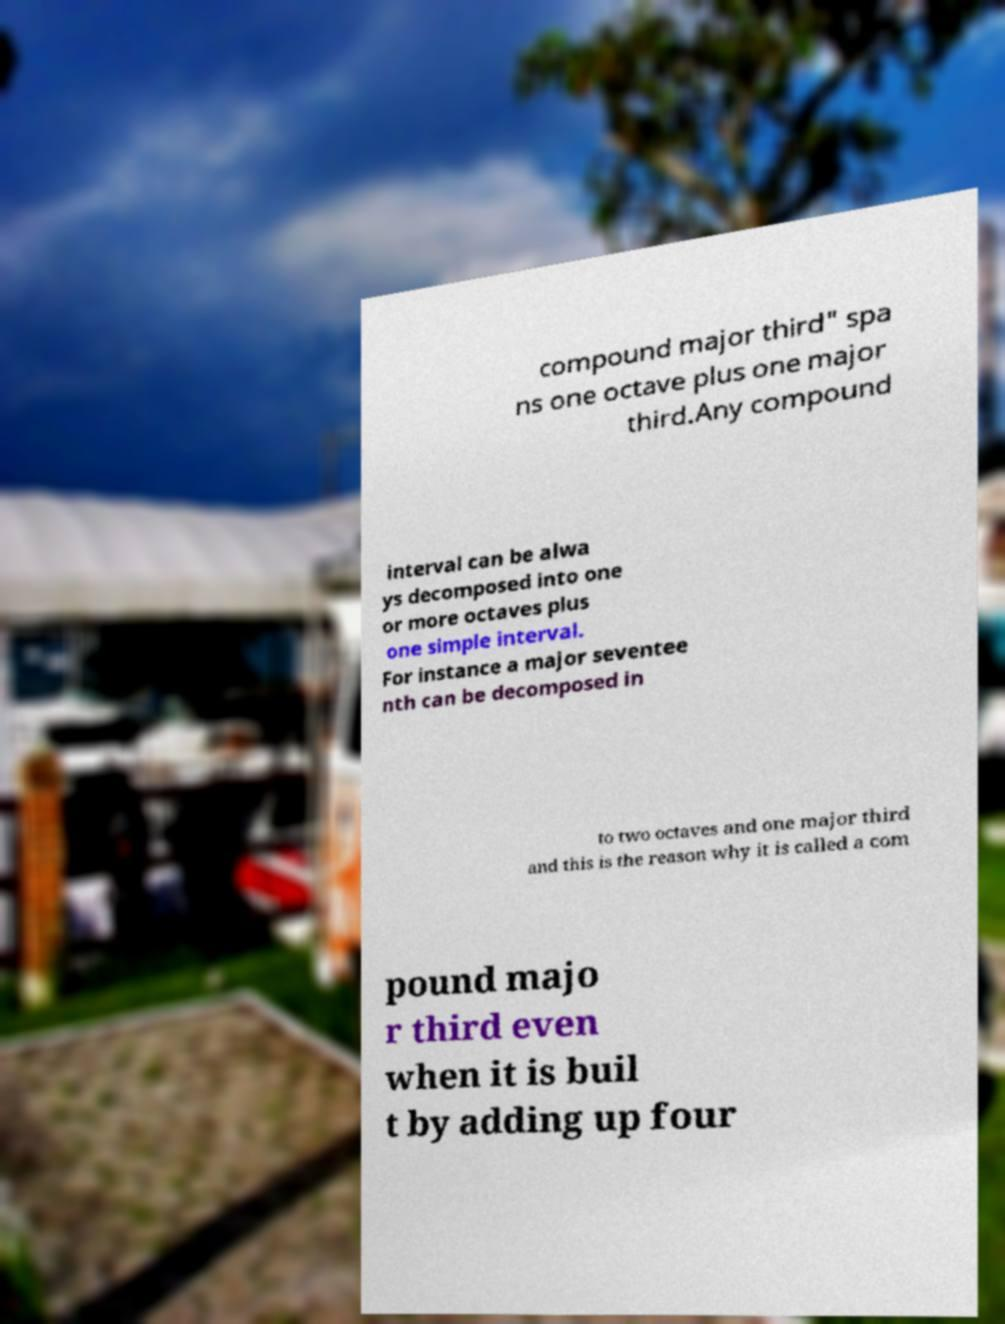For documentation purposes, I need the text within this image transcribed. Could you provide that? compound major third" spa ns one octave plus one major third.Any compound interval can be alwa ys decomposed into one or more octaves plus one simple interval. For instance a major seventee nth can be decomposed in to two octaves and one major third and this is the reason why it is called a com pound majo r third even when it is buil t by adding up four 